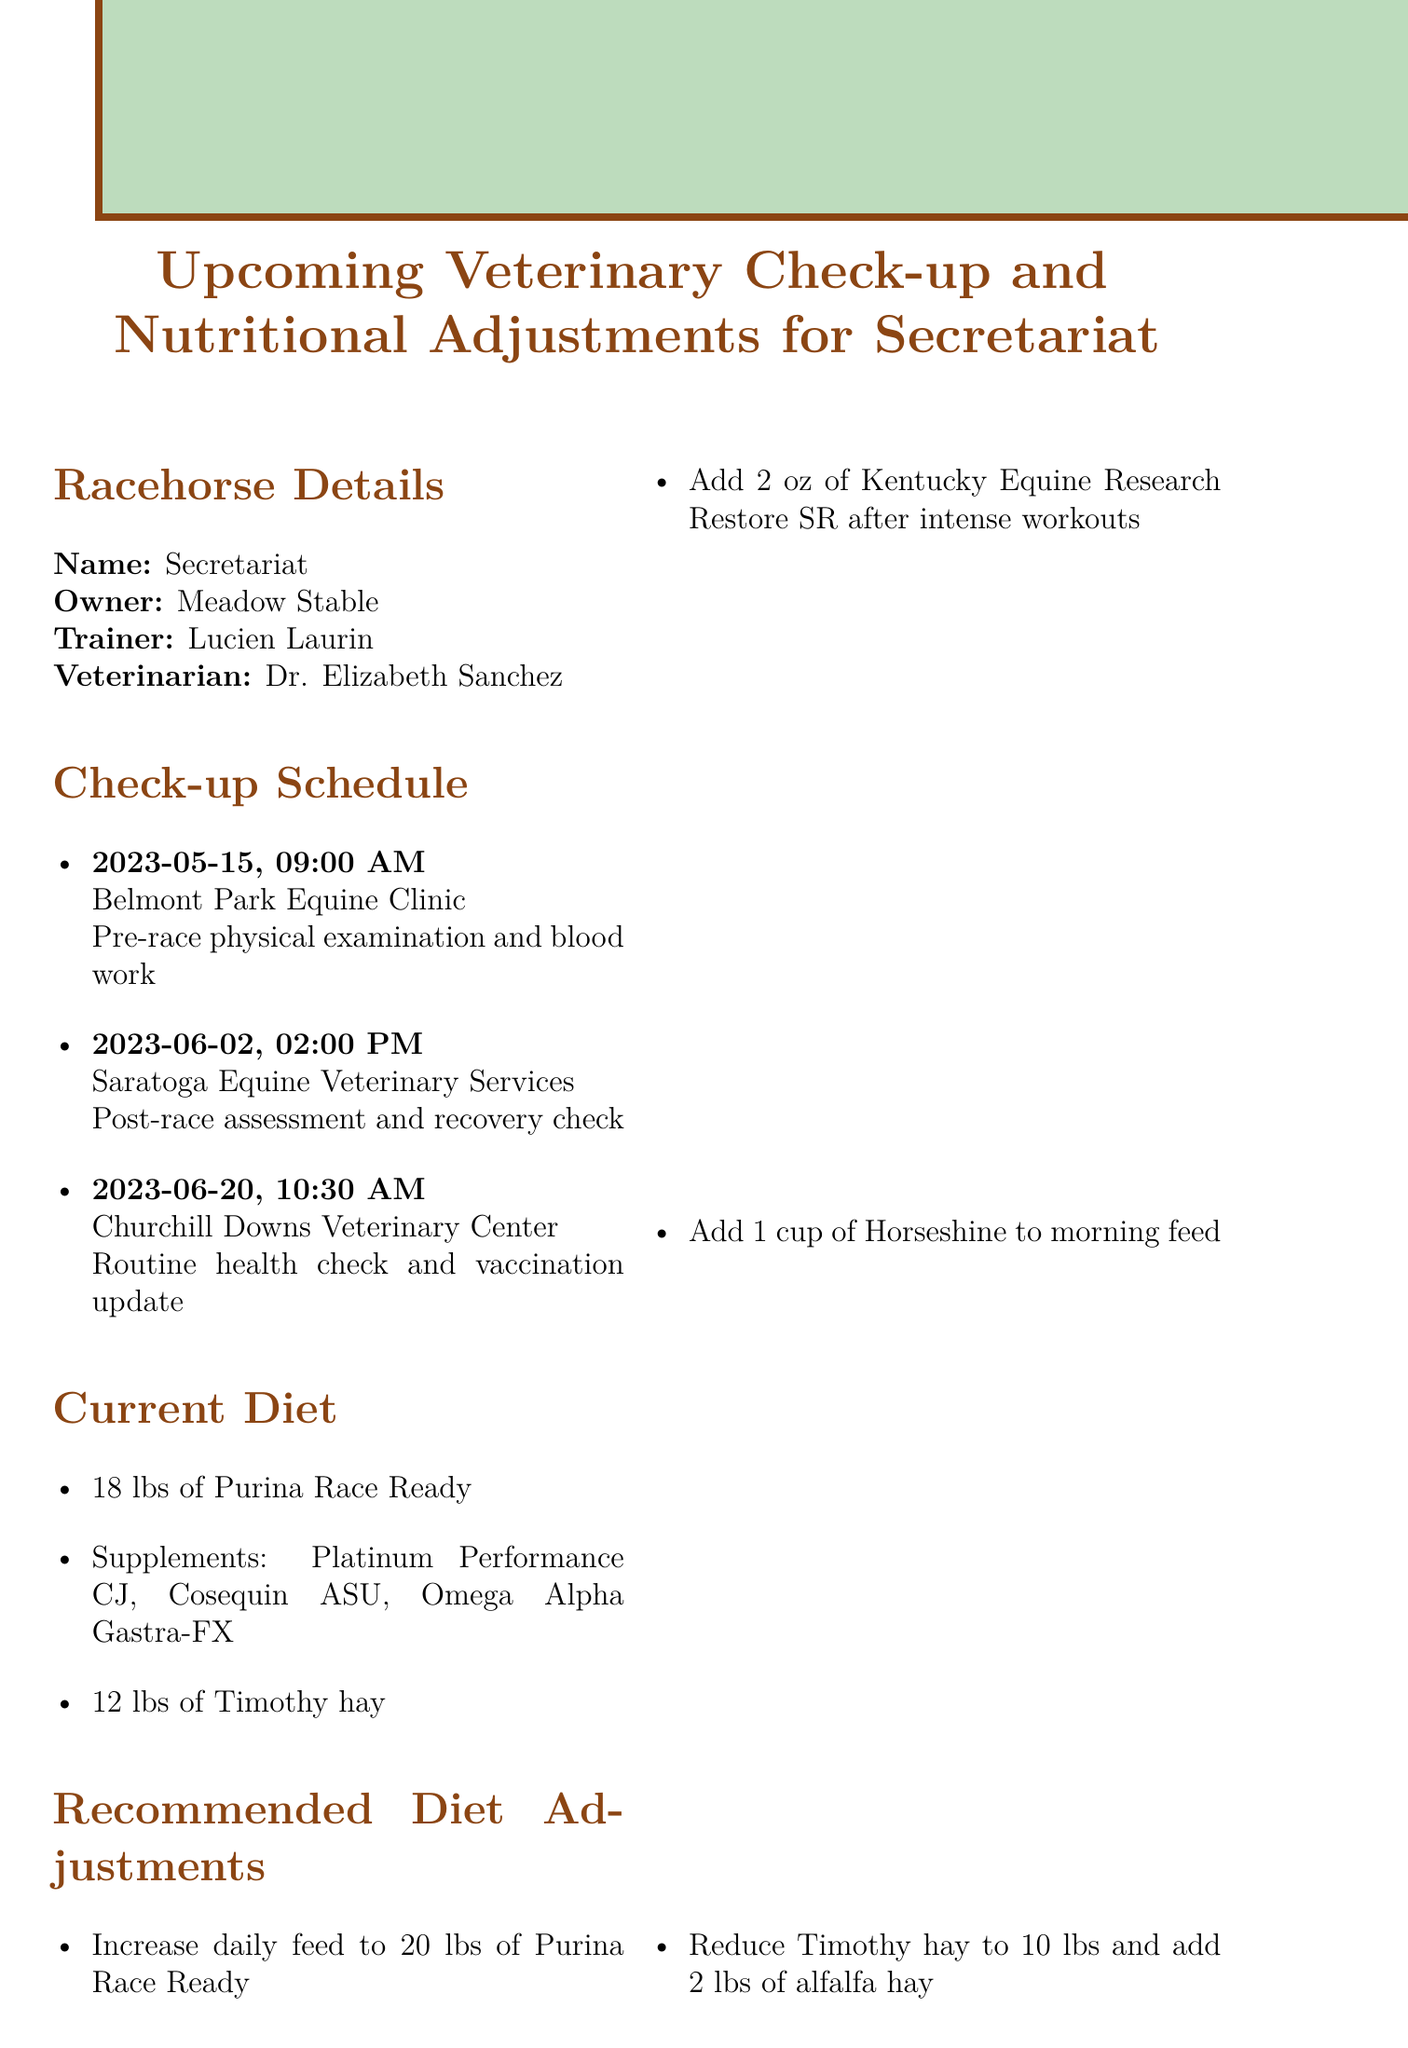What is the name of the racehorse? The racehorse's name is outlined in the document as "Secretariat."
Answer: Secretariat Who is the veterinarian for Secretariat? The veterinarian assigned to Secretariat is mentioned, which is "Dr. Elizabeth Sanchez."
Answer: Dr. Elizabeth Sanchez When is the next check-up date? The upcoming check-up dates are provided, and the next one is "2023-06-02."
Answer: 2023-06-02 What is the current daily feed amount? The document specifies the current daily feed amount for Secretariat as "18 lbs of Purina Race Ready."
Answer: 18 lbs of Purina Race Ready What is the purpose of the check-up on May 15, 2023? The purpose of the check-up on this date is listed in the document as "Pre-race physical examination and blood work."
Answer: Pre-race physical examination and blood work How much Timothy hay is Secretariat currently receiving? The document states the current amount of Timothy hay is "12 lbs."
Answer: 12 lbs What is the recommended increase for daily feed? The memo recommends increasing the daily feed to "20 lbs of Purina Race Ready."
Answer: 20 lbs of Purina Race Ready What should be monitored during warmer weather? The special considerations section advises to "Monitor water intake during warmer weather."
Answer: Monitor water intake What is one of the upcoming races? The future races are listed, and one of them is the "Belmont Stakes."
Answer: Belmont Stakes 